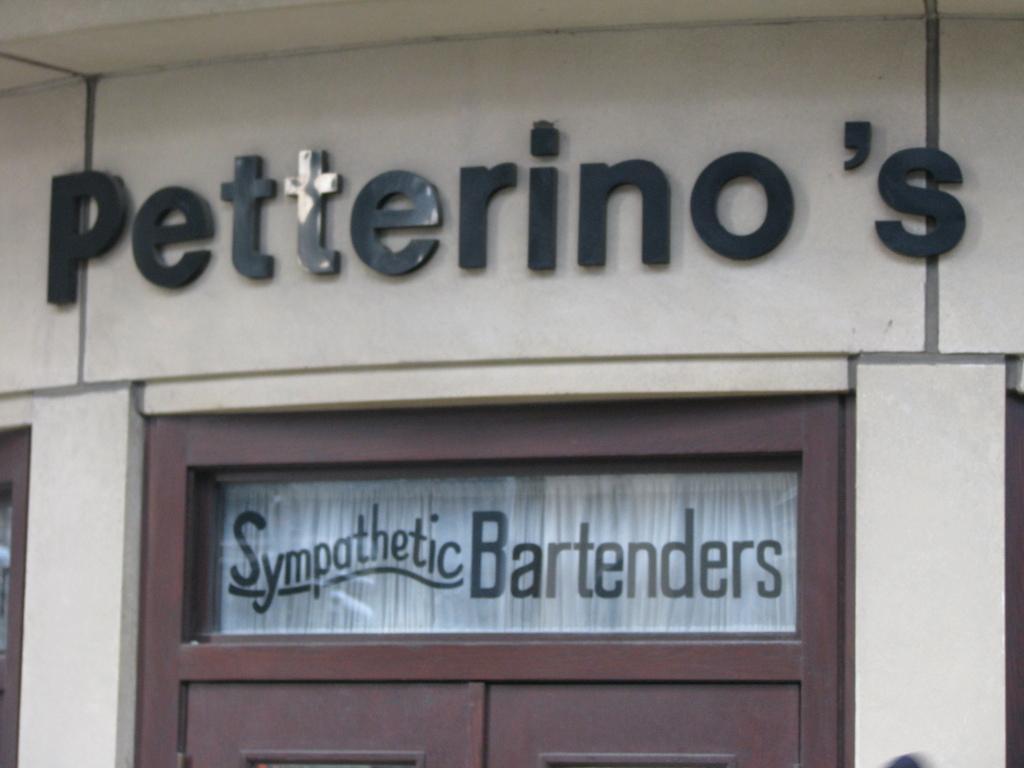How would you summarize this image in a sentence or two? In this image we can see the sign board to the wall. Here we can see the wooden door and here we can see the glass on which we can see some text. 